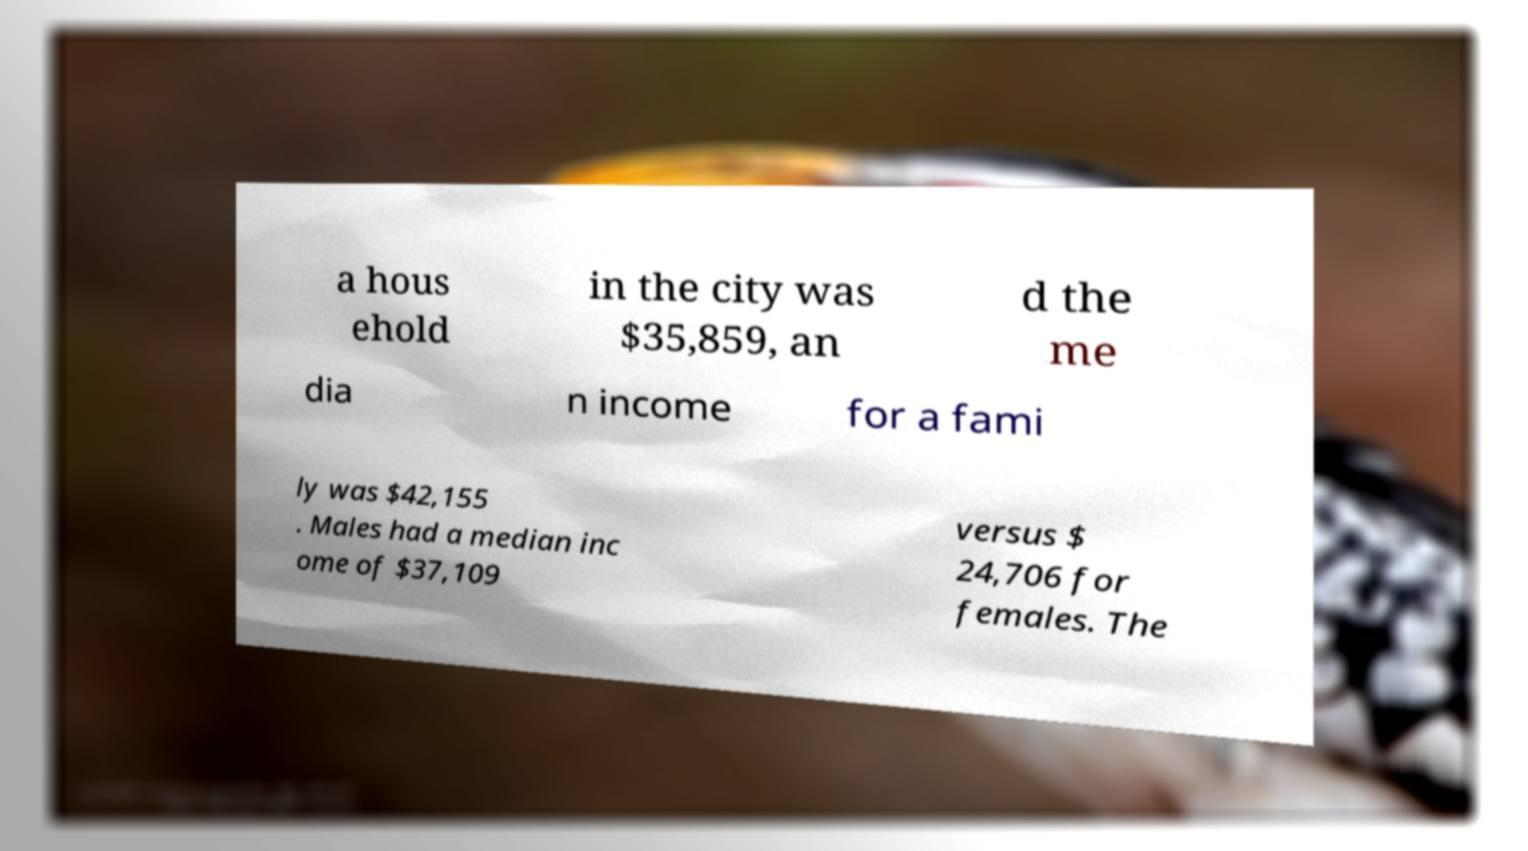Please identify and transcribe the text found in this image. a hous ehold in the city was $35,859, an d the me dia n income for a fami ly was $42,155 . Males had a median inc ome of $37,109 versus $ 24,706 for females. The 